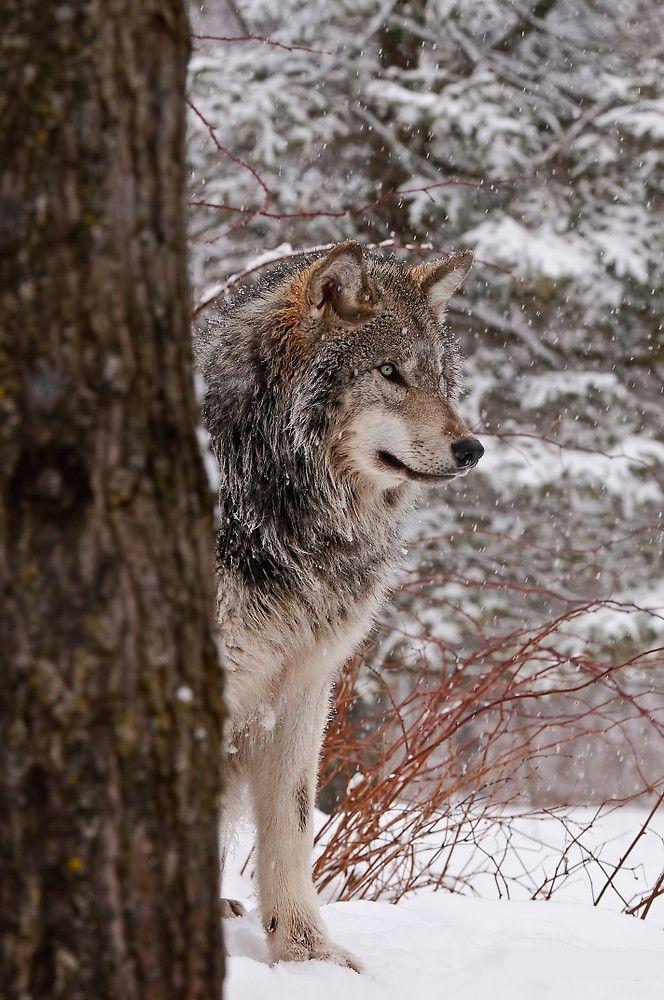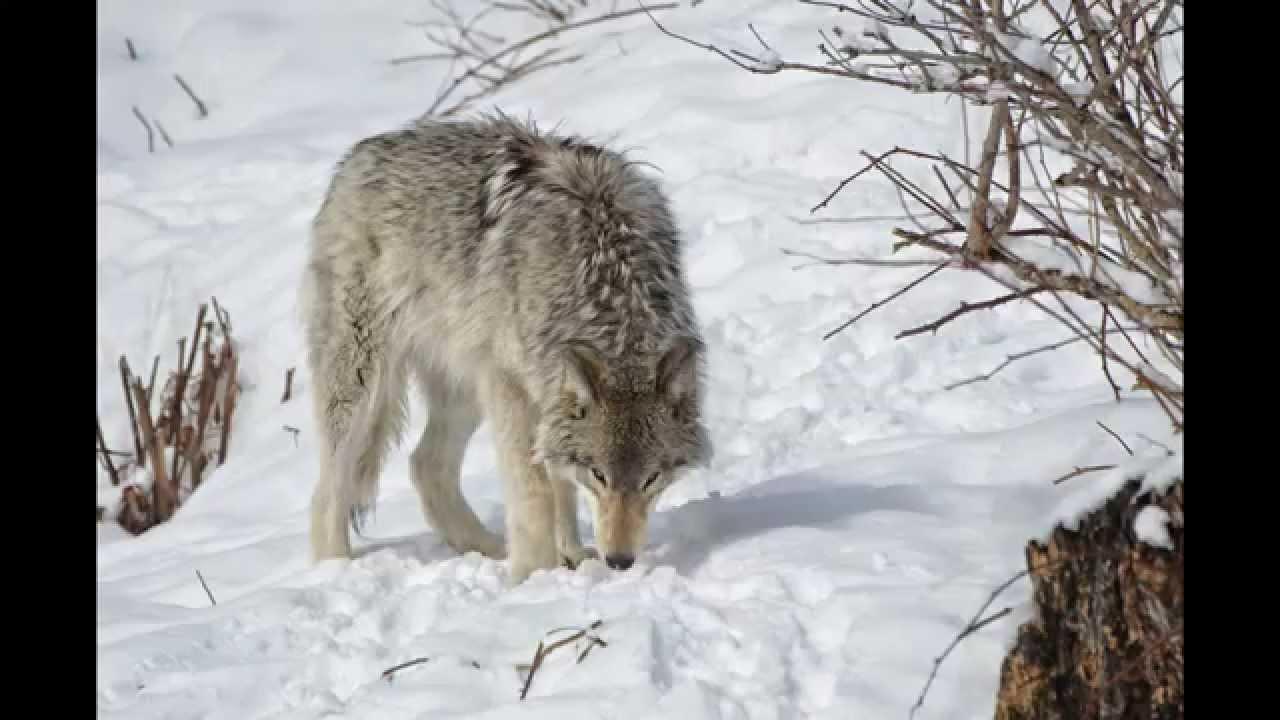The first image is the image on the left, the second image is the image on the right. For the images shown, is this caption "Each image contains exactly one wolf, and all wolves shown are upright instead of reclining." true? Answer yes or no. Yes. 